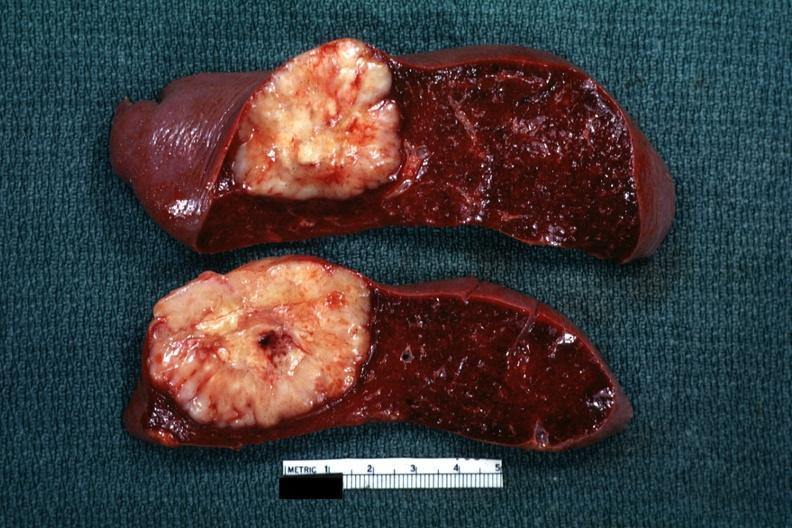what was reticulum cell sarcoma?
Answer the question using a single word or phrase. Diagnosis 